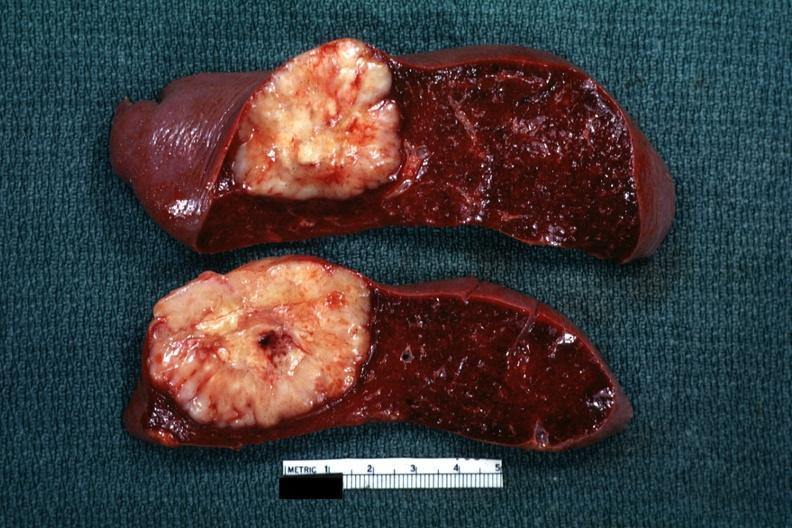what was reticulum cell sarcoma?
Answer the question using a single word or phrase. Diagnosis 